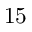<formula> <loc_0><loc_0><loc_500><loc_500>1 5</formula> 